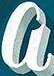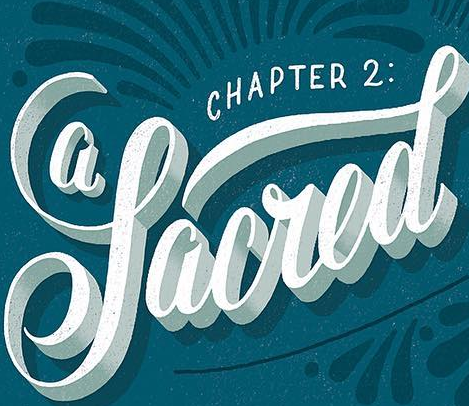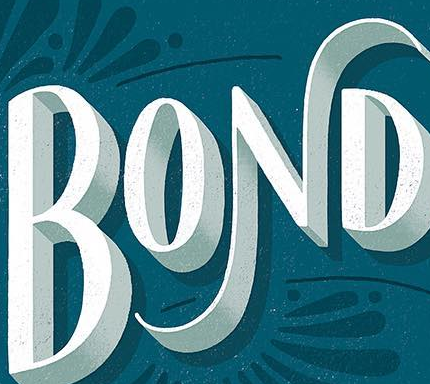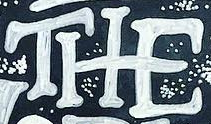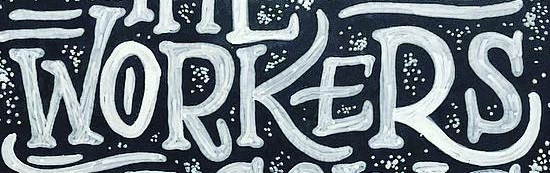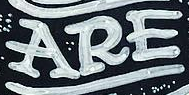Read the text content from these images in order, separated by a semicolon. a; Sacred; BOND; THE; WORKERS; ARE 